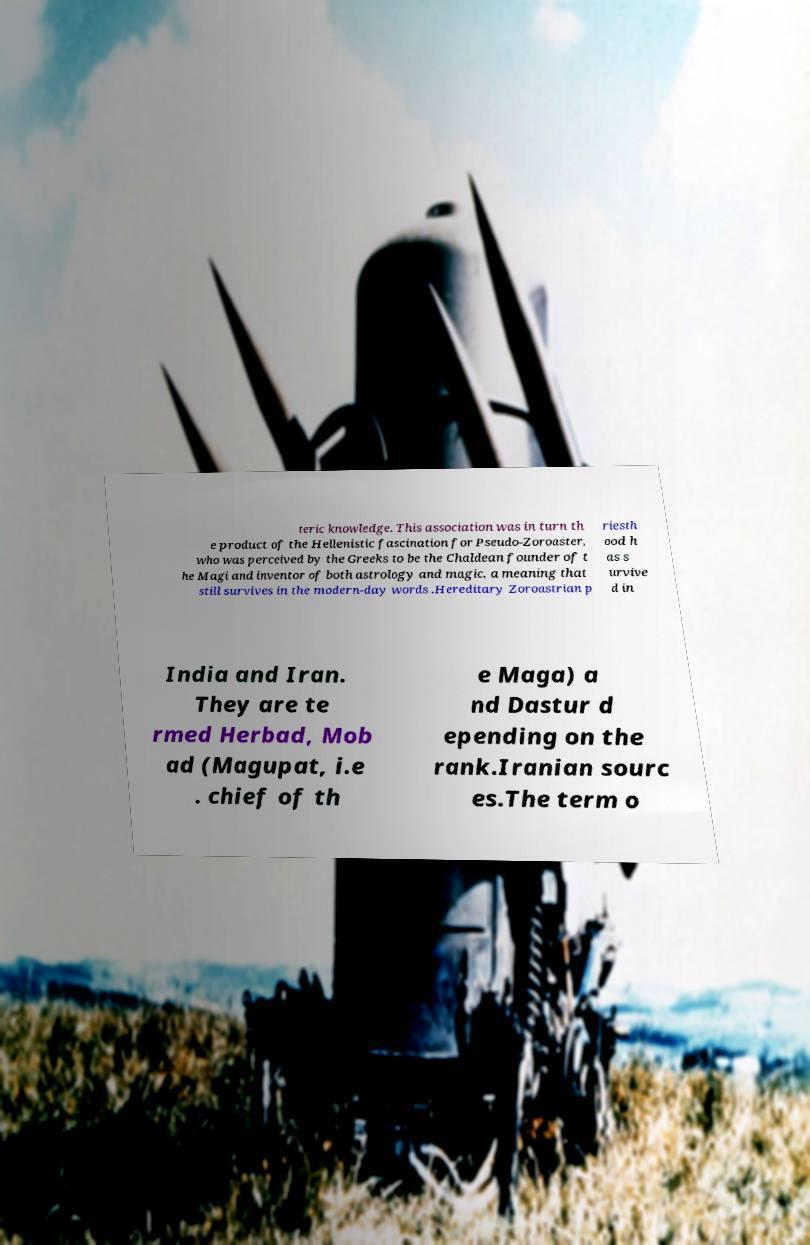Could you extract and type out the text from this image? teric knowledge. This association was in turn th e product of the Hellenistic fascination for Pseudo-Zoroaster, who was perceived by the Greeks to be the Chaldean founder of t he Magi and inventor of both astrology and magic, a meaning that still survives in the modern-day words .Hereditary Zoroastrian p riesth ood h as s urvive d in India and Iran. They are te rmed Herbad, Mob ad (Magupat, i.e . chief of th e Maga) a nd Dastur d epending on the rank.Iranian sourc es.The term o 